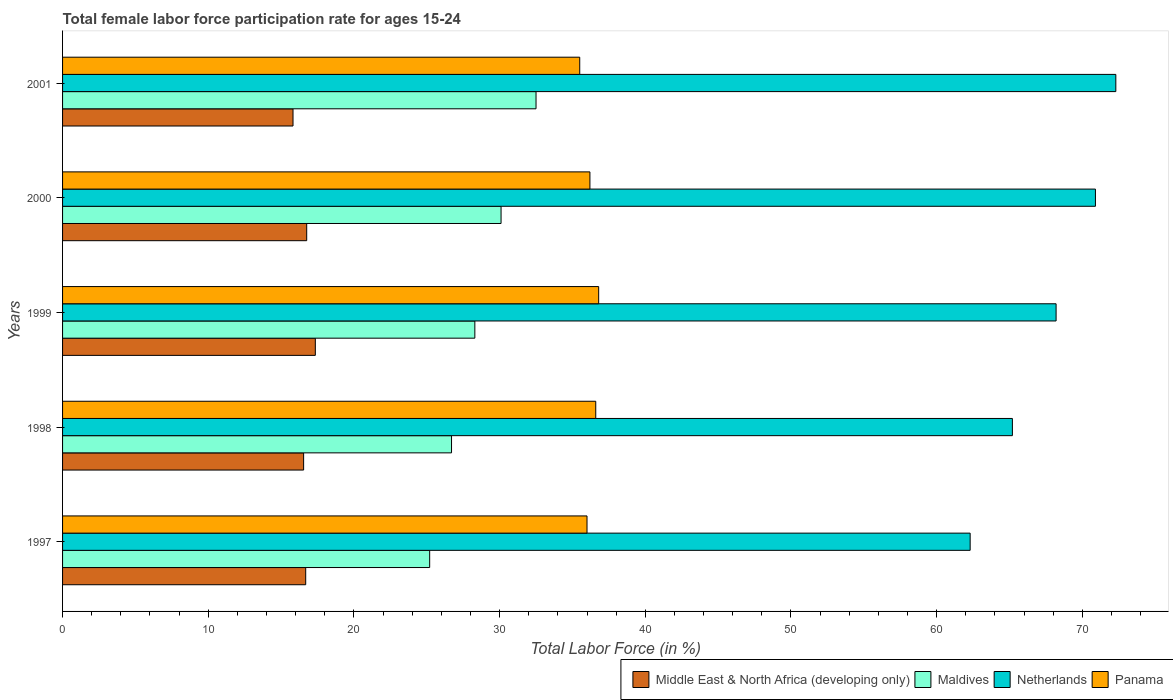How many groups of bars are there?
Your answer should be compact. 5. Are the number of bars per tick equal to the number of legend labels?
Give a very brief answer. Yes. How many bars are there on the 5th tick from the top?
Offer a terse response. 4. What is the label of the 3rd group of bars from the top?
Your response must be concise. 1999. What is the female labor force participation rate in Maldives in 2000?
Offer a very short reply. 30.1. Across all years, what is the maximum female labor force participation rate in Middle East & North Africa (developing only)?
Your answer should be compact. 17.35. Across all years, what is the minimum female labor force participation rate in Middle East & North Africa (developing only)?
Make the answer very short. 15.82. In which year was the female labor force participation rate in Middle East & North Africa (developing only) minimum?
Ensure brevity in your answer.  2001. What is the total female labor force participation rate in Panama in the graph?
Ensure brevity in your answer.  181.1. What is the difference between the female labor force participation rate in Middle East & North Africa (developing only) in 1999 and that in 2001?
Your response must be concise. 1.53. What is the difference between the female labor force participation rate in Maldives in 2000 and the female labor force participation rate in Panama in 2001?
Give a very brief answer. -5.4. What is the average female labor force participation rate in Netherlands per year?
Your answer should be compact. 67.78. In the year 1999, what is the difference between the female labor force participation rate in Maldives and female labor force participation rate in Panama?
Offer a very short reply. -8.5. What is the ratio of the female labor force participation rate in Panama in 1997 to that in 2001?
Provide a succinct answer. 1.01. What is the difference between the highest and the second highest female labor force participation rate in Netherlands?
Provide a succinct answer. 1.4. What is the difference between the highest and the lowest female labor force participation rate in Panama?
Provide a short and direct response. 1.3. In how many years, is the female labor force participation rate in Middle East & North Africa (developing only) greater than the average female labor force participation rate in Middle East & North Africa (developing only) taken over all years?
Give a very brief answer. 3. Is the sum of the female labor force participation rate in Maldives in 1998 and 2000 greater than the maximum female labor force participation rate in Netherlands across all years?
Offer a very short reply. No. What does the 1st bar from the top in 1998 represents?
Your response must be concise. Panama. What does the 2nd bar from the bottom in 2001 represents?
Offer a very short reply. Maldives. Is it the case that in every year, the sum of the female labor force participation rate in Panama and female labor force participation rate in Maldives is greater than the female labor force participation rate in Netherlands?
Give a very brief answer. No. How many bars are there?
Offer a very short reply. 20. How many years are there in the graph?
Your response must be concise. 5. What is the difference between two consecutive major ticks on the X-axis?
Keep it short and to the point. 10. What is the title of the graph?
Provide a succinct answer. Total female labor force participation rate for ages 15-24. Does "Algeria" appear as one of the legend labels in the graph?
Provide a succinct answer. No. What is the Total Labor Force (in %) of Middle East & North Africa (developing only) in 1997?
Provide a succinct answer. 16.69. What is the Total Labor Force (in %) of Maldives in 1997?
Your answer should be very brief. 25.2. What is the Total Labor Force (in %) in Netherlands in 1997?
Provide a short and direct response. 62.3. What is the Total Labor Force (in %) in Middle East & North Africa (developing only) in 1998?
Ensure brevity in your answer.  16.55. What is the Total Labor Force (in %) of Maldives in 1998?
Give a very brief answer. 26.7. What is the Total Labor Force (in %) of Netherlands in 1998?
Provide a short and direct response. 65.2. What is the Total Labor Force (in %) in Panama in 1998?
Give a very brief answer. 36.6. What is the Total Labor Force (in %) of Middle East & North Africa (developing only) in 1999?
Keep it short and to the point. 17.35. What is the Total Labor Force (in %) in Maldives in 1999?
Keep it short and to the point. 28.3. What is the Total Labor Force (in %) of Netherlands in 1999?
Your response must be concise. 68.2. What is the Total Labor Force (in %) of Panama in 1999?
Keep it short and to the point. 36.8. What is the Total Labor Force (in %) in Middle East & North Africa (developing only) in 2000?
Your response must be concise. 16.76. What is the Total Labor Force (in %) of Maldives in 2000?
Offer a very short reply. 30.1. What is the Total Labor Force (in %) in Netherlands in 2000?
Provide a succinct answer. 70.9. What is the Total Labor Force (in %) of Panama in 2000?
Make the answer very short. 36.2. What is the Total Labor Force (in %) of Middle East & North Africa (developing only) in 2001?
Keep it short and to the point. 15.82. What is the Total Labor Force (in %) in Maldives in 2001?
Provide a succinct answer. 32.5. What is the Total Labor Force (in %) of Netherlands in 2001?
Ensure brevity in your answer.  72.3. What is the Total Labor Force (in %) in Panama in 2001?
Ensure brevity in your answer.  35.5. Across all years, what is the maximum Total Labor Force (in %) of Middle East & North Africa (developing only)?
Provide a short and direct response. 17.35. Across all years, what is the maximum Total Labor Force (in %) in Maldives?
Make the answer very short. 32.5. Across all years, what is the maximum Total Labor Force (in %) of Netherlands?
Your answer should be very brief. 72.3. Across all years, what is the maximum Total Labor Force (in %) of Panama?
Provide a succinct answer. 36.8. Across all years, what is the minimum Total Labor Force (in %) in Middle East & North Africa (developing only)?
Keep it short and to the point. 15.82. Across all years, what is the minimum Total Labor Force (in %) of Maldives?
Provide a succinct answer. 25.2. Across all years, what is the minimum Total Labor Force (in %) of Netherlands?
Ensure brevity in your answer.  62.3. Across all years, what is the minimum Total Labor Force (in %) of Panama?
Provide a succinct answer. 35.5. What is the total Total Labor Force (in %) of Middle East & North Africa (developing only) in the graph?
Provide a succinct answer. 83.17. What is the total Total Labor Force (in %) in Maldives in the graph?
Your answer should be compact. 142.8. What is the total Total Labor Force (in %) in Netherlands in the graph?
Your answer should be very brief. 338.9. What is the total Total Labor Force (in %) in Panama in the graph?
Make the answer very short. 181.1. What is the difference between the Total Labor Force (in %) in Middle East & North Africa (developing only) in 1997 and that in 1998?
Offer a terse response. 0.14. What is the difference between the Total Labor Force (in %) in Netherlands in 1997 and that in 1998?
Your response must be concise. -2.9. What is the difference between the Total Labor Force (in %) in Middle East & North Africa (developing only) in 1997 and that in 1999?
Ensure brevity in your answer.  -0.66. What is the difference between the Total Labor Force (in %) of Netherlands in 1997 and that in 1999?
Your response must be concise. -5.9. What is the difference between the Total Labor Force (in %) of Panama in 1997 and that in 1999?
Your answer should be compact. -0.8. What is the difference between the Total Labor Force (in %) in Middle East & North Africa (developing only) in 1997 and that in 2000?
Your response must be concise. -0.07. What is the difference between the Total Labor Force (in %) of Maldives in 1997 and that in 2000?
Make the answer very short. -4.9. What is the difference between the Total Labor Force (in %) in Netherlands in 1997 and that in 2000?
Your answer should be compact. -8.6. What is the difference between the Total Labor Force (in %) of Panama in 1997 and that in 2000?
Provide a succinct answer. -0.2. What is the difference between the Total Labor Force (in %) of Middle East & North Africa (developing only) in 1997 and that in 2001?
Make the answer very short. 0.87. What is the difference between the Total Labor Force (in %) of Middle East & North Africa (developing only) in 1998 and that in 1999?
Your answer should be compact. -0.8. What is the difference between the Total Labor Force (in %) in Middle East & North Africa (developing only) in 1998 and that in 2000?
Provide a short and direct response. -0.21. What is the difference between the Total Labor Force (in %) in Panama in 1998 and that in 2000?
Your answer should be compact. 0.4. What is the difference between the Total Labor Force (in %) in Middle East & North Africa (developing only) in 1998 and that in 2001?
Your answer should be very brief. 0.73. What is the difference between the Total Labor Force (in %) of Netherlands in 1998 and that in 2001?
Offer a very short reply. -7.1. What is the difference between the Total Labor Force (in %) in Panama in 1998 and that in 2001?
Provide a short and direct response. 1.1. What is the difference between the Total Labor Force (in %) in Middle East & North Africa (developing only) in 1999 and that in 2000?
Ensure brevity in your answer.  0.59. What is the difference between the Total Labor Force (in %) of Maldives in 1999 and that in 2000?
Your answer should be compact. -1.8. What is the difference between the Total Labor Force (in %) of Netherlands in 1999 and that in 2000?
Provide a short and direct response. -2.7. What is the difference between the Total Labor Force (in %) in Middle East & North Africa (developing only) in 1999 and that in 2001?
Provide a short and direct response. 1.53. What is the difference between the Total Labor Force (in %) of Middle East & North Africa (developing only) in 2000 and that in 2001?
Offer a very short reply. 0.94. What is the difference between the Total Labor Force (in %) in Maldives in 2000 and that in 2001?
Provide a succinct answer. -2.4. What is the difference between the Total Labor Force (in %) of Panama in 2000 and that in 2001?
Offer a very short reply. 0.7. What is the difference between the Total Labor Force (in %) of Middle East & North Africa (developing only) in 1997 and the Total Labor Force (in %) of Maldives in 1998?
Provide a succinct answer. -10.01. What is the difference between the Total Labor Force (in %) of Middle East & North Africa (developing only) in 1997 and the Total Labor Force (in %) of Netherlands in 1998?
Your answer should be very brief. -48.51. What is the difference between the Total Labor Force (in %) of Middle East & North Africa (developing only) in 1997 and the Total Labor Force (in %) of Panama in 1998?
Offer a terse response. -19.91. What is the difference between the Total Labor Force (in %) of Maldives in 1997 and the Total Labor Force (in %) of Netherlands in 1998?
Provide a short and direct response. -40. What is the difference between the Total Labor Force (in %) of Netherlands in 1997 and the Total Labor Force (in %) of Panama in 1998?
Provide a succinct answer. 25.7. What is the difference between the Total Labor Force (in %) of Middle East & North Africa (developing only) in 1997 and the Total Labor Force (in %) of Maldives in 1999?
Offer a very short reply. -11.61. What is the difference between the Total Labor Force (in %) in Middle East & North Africa (developing only) in 1997 and the Total Labor Force (in %) in Netherlands in 1999?
Your answer should be very brief. -51.51. What is the difference between the Total Labor Force (in %) of Middle East & North Africa (developing only) in 1997 and the Total Labor Force (in %) of Panama in 1999?
Provide a short and direct response. -20.11. What is the difference between the Total Labor Force (in %) in Maldives in 1997 and the Total Labor Force (in %) in Netherlands in 1999?
Provide a succinct answer. -43. What is the difference between the Total Labor Force (in %) of Maldives in 1997 and the Total Labor Force (in %) of Panama in 1999?
Ensure brevity in your answer.  -11.6. What is the difference between the Total Labor Force (in %) in Middle East & North Africa (developing only) in 1997 and the Total Labor Force (in %) in Maldives in 2000?
Offer a very short reply. -13.41. What is the difference between the Total Labor Force (in %) in Middle East & North Africa (developing only) in 1997 and the Total Labor Force (in %) in Netherlands in 2000?
Make the answer very short. -54.21. What is the difference between the Total Labor Force (in %) of Middle East & North Africa (developing only) in 1997 and the Total Labor Force (in %) of Panama in 2000?
Provide a succinct answer. -19.51. What is the difference between the Total Labor Force (in %) of Maldives in 1997 and the Total Labor Force (in %) of Netherlands in 2000?
Offer a very short reply. -45.7. What is the difference between the Total Labor Force (in %) in Netherlands in 1997 and the Total Labor Force (in %) in Panama in 2000?
Provide a succinct answer. 26.1. What is the difference between the Total Labor Force (in %) in Middle East & North Africa (developing only) in 1997 and the Total Labor Force (in %) in Maldives in 2001?
Offer a very short reply. -15.81. What is the difference between the Total Labor Force (in %) of Middle East & North Africa (developing only) in 1997 and the Total Labor Force (in %) of Netherlands in 2001?
Ensure brevity in your answer.  -55.61. What is the difference between the Total Labor Force (in %) in Middle East & North Africa (developing only) in 1997 and the Total Labor Force (in %) in Panama in 2001?
Provide a succinct answer. -18.81. What is the difference between the Total Labor Force (in %) in Maldives in 1997 and the Total Labor Force (in %) in Netherlands in 2001?
Your response must be concise. -47.1. What is the difference between the Total Labor Force (in %) of Netherlands in 1997 and the Total Labor Force (in %) of Panama in 2001?
Your response must be concise. 26.8. What is the difference between the Total Labor Force (in %) in Middle East & North Africa (developing only) in 1998 and the Total Labor Force (in %) in Maldives in 1999?
Offer a terse response. -11.75. What is the difference between the Total Labor Force (in %) in Middle East & North Africa (developing only) in 1998 and the Total Labor Force (in %) in Netherlands in 1999?
Offer a very short reply. -51.65. What is the difference between the Total Labor Force (in %) in Middle East & North Africa (developing only) in 1998 and the Total Labor Force (in %) in Panama in 1999?
Your response must be concise. -20.25. What is the difference between the Total Labor Force (in %) of Maldives in 1998 and the Total Labor Force (in %) of Netherlands in 1999?
Your response must be concise. -41.5. What is the difference between the Total Labor Force (in %) in Netherlands in 1998 and the Total Labor Force (in %) in Panama in 1999?
Give a very brief answer. 28.4. What is the difference between the Total Labor Force (in %) in Middle East & North Africa (developing only) in 1998 and the Total Labor Force (in %) in Maldives in 2000?
Offer a very short reply. -13.55. What is the difference between the Total Labor Force (in %) in Middle East & North Africa (developing only) in 1998 and the Total Labor Force (in %) in Netherlands in 2000?
Ensure brevity in your answer.  -54.35. What is the difference between the Total Labor Force (in %) of Middle East & North Africa (developing only) in 1998 and the Total Labor Force (in %) of Panama in 2000?
Your response must be concise. -19.65. What is the difference between the Total Labor Force (in %) in Maldives in 1998 and the Total Labor Force (in %) in Netherlands in 2000?
Your answer should be very brief. -44.2. What is the difference between the Total Labor Force (in %) in Netherlands in 1998 and the Total Labor Force (in %) in Panama in 2000?
Ensure brevity in your answer.  29. What is the difference between the Total Labor Force (in %) of Middle East & North Africa (developing only) in 1998 and the Total Labor Force (in %) of Maldives in 2001?
Your answer should be compact. -15.95. What is the difference between the Total Labor Force (in %) of Middle East & North Africa (developing only) in 1998 and the Total Labor Force (in %) of Netherlands in 2001?
Give a very brief answer. -55.75. What is the difference between the Total Labor Force (in %) of Middle East & North Africa (developing only) in 1998 and the Total Labor Force (in %) of Panama in 2001?
Ensure brevity in your answer.  -18.95. What is the difference between the Total Labor Force (in %) in Maldives in 1998 and the Total Labor Force (in %) in Netherlands in 2001?
Give a very brief answer. -45.6. What is the difference between the Total Labor Force (in %) of Netherlands in 1998 and the Total Labor Force (in %) of Panama in 2001?
Make the answer very short. 29.7. What is the difference between the Total Labor Force (in %) of Middle East & North Africa (developing only) in 1999 and the Total Labor Force (in %) of Maldives in 2000?
Offer a terse response. -12.75. What is the difference between the Total Labor Force (in %) in Middle East & North Africa (developing only) in 1999 and the Total Labor Force (in %) in Netherlands in 2000?
Your answer should be very brief. -53.55. What is the difference between the Total Labor Force (in %) in Middle East & North Africa (developing only) in 1999 and the Total Labor Force (in %) in Panama in 2000?
Keep it short and to the point. -18.85. What is the difference between the Total Labor Force (in %) of Maldives in 1999 and the Total Labor Force (in %) of Netherlands in 2000?
Your response must be concise. -42.6. What is the difference between the Total Labor Force (in %) in Maldives in 1999 and the Total Labor Force (in %) in Panama in 2000?
Make the answer very short. -7.9. What is the difference between the Total Labor Force (in %) in Netherlands in 1999 and the Total Labor Force (in %) in Panama in 2000?
Offer a terse response. 32. What is the difference between the Total Labor Force (in %) of Middle East & North Africa (developing only) in 1999 and the Total Labor Force (in %) of Maldives in 2001?
Your answer should be very brief. -15.15. What is the difference between the Total Labor Force (in %) in Middle East & North Africa (developing only) in 1999 and the Total Labor Force (in %) in Netherlands in 2001?
Keep it short and to the point. -54.95. What is the difference between the Total Labor Force (in %) of Middle East & North Africa (developing only) in 1999 and the Total Labor Force (in %) of Panama in 2001?
Provide a short and direct response. -18.15. What is the difference between the Total Labor Force (in %) of Maldives in 1999 and the Total Labor Force (in %) of Netherlands in 2001?
Provide a succinct answer. -44. What is the difference between the Total Labor Force (in %) of Netherlands in 1999 and the Total Labor Force (in %) of Panama in 2001?
Offer a very short reply. 32.7. What is the difference between the Total Labor Force (in %) of Middle East & North Africa (developing only) in 2000 and the Total Labor Force (in %) of Maldives in 2001?
Give a very brief answer. -15.74. What is the difference between the Total Labor Force (in %) in Middle East & North Africa (developing only) in 2000 and the Total Labor Force (in %) in Netherlands in 2001?
Your answer should be compact. -55.54. What is the difference between the Total Labor Force (in %) in Middle East & North Africa (developing only) in 2000 and the Total Labor Force (in %) in Panama in 2001?
Give a very brief answer. -18.74. What is the difference between the Total Labor Force (in %) in Maldives in 2000 and the Total Labor Force (in %) in Netherlands in 2001?
Make the answer very short. -42.2. What is the difference between the Total Labor Force (in %) of Netherlands in 2000 and the Total Labor Force (in %) of Panama in 2001?
Keep it short and to the point. 35.4. What is the average Total Labor Force (in %) in Middle East & North Africa (developing only) per year?
Your answer should be very brief. 16.63. What is the average Total Labor Force (in %) of Maldives per year?
Offer a terse response. 28.56. What is the average Total Labor Force (in %) of Netherlands per year?
Your answer should be very brief. 67.78. What is the average Total Labor Force (in %) of Panama per year?
Your answer should be compact. 36.22. In the year 1997, what is the difference between the Total Labor Force (in %) in Middle East & North Africa (developing only) and Total Labor Force (in %) in Maldives?
Offer a terse response. -8.51. In the year 1997, what is the difference between the Total Labor Force (in %) in Middle East & North Africa (developing only) and Total Labor Force (in %) in Netherlands?
Offer a very short reply. -45.61. In the year 1997, what is the difference between the Total Labor Force (in %) of Middle East & North Africa (developing only) and Total Labor Force (in %) of Panama?
Your answer should be very brief. -19.31. In the year 1997, what is the difference between the Total Labor Force (in %) in Maldives and Total Labor Force (in %) in Netherlands?
Offer a terse response. -37.1. In the year 1997, what is the difference between the Total Labor Force (in %) in Maldives and Total Labor Force (in %) in Panama?
Give a very brief answer. -10.8. In the year 1997, what is the difference between the Total Labor Force (in %) of Netherlands and Total Labor Force (in %) of Panama?
Ensure brevity in your answer.  26.3. In the year 1998, what is the difference between the Total Labor Force (in %) in Middle East & North Africa (developing only) and Total Labor Force (in %) in Maldives?
Your response must be concise. -10.15. In the year 1998, what is the difference between the Total Labor Force (in %) of Middle East & North Africa (developing only) and Total Labor Force (in %) of Netherlands?
Make the answer very short. -48.65. In the year 1998, what is the difference between the Total Labor Force (in %) of Middle East & North Africa (developing only) and Total Labor Force (in %) of Panama?
Give a very brief answer. -20.05. In the year 1998, what is the difference between the Total Labor Force (in %) in Maldives and Total Labor Force (in %) in Netherlands?
Keep it short and to the point. -38.5. In the year 1998, what is the difference between the Total Labor Force (in %) in Netherlands and Total Labor Force (in %) in Panama?
Offer a very short reply. 28.6. In the year 1999, what is the difference between the Total Labor Force (in %) of Middle East & North Africa (developing only) and Total Labor Force (in %) of Maldives?
Keep it short and to the point. -10.95. In the year 1999, what is the difference between the Total Labor Force (in %) in Middle East & North Africa (developing only) and Total Labor Force (in %) in Netherlands?
Your answer should be compact. -50.85. In the year 1999, what is the difference between the Total Labor Force (in %) of Middle East & North Africa (developing only) and Total Labor Force (in %) of Panama?
Offer a terse response. -19.45. In the year 1999, what is the difference between the Total Labor Force (in %) of Maldives and Total Labor Force (in %) of Netherlands?
Your answer should be very brief. -39.9. In the year 1999, what is the difference between the Total Labor Force (in %) of Netherlands and Total Labor Force (in %) of Panama?
Ensure brevity in your answer.  31.4. In the year 2000, what is the difference between the Total Labor Force (in %) in Middle East & North Africa (developing only) and Total Labor Force (in %) in Maldives?
Your answer should be very brief. -13.34. In the year 2000, what is the difference between the Total Labor Force (in %) in Middle East & North Africa (developing only) and Total Labor Force (in %) in Netherlands?
Offer a terse response. -54.14. In the year 2000, what is the difference between the Total Labor Force (in %) of Middle East & North Africa (developing only) and Total Labor Force (in %) of Panama?
Keep it short and to the point. -19.44. In the year 2000, what is the difference between the Total Labor Force (in %) in Maldives and Total Labor Force (in %) in Netherlands?
Give a very brief answer. -40.8. In the year 2000, what is the difference between the Total Labor Force (in %) in Maldives and Total Labor Force (in %) in Panama?
Your answer should be compact. -6.1. In the year 2000, what is the difference between the Total Labor Force (in %) in Netherlands and Total Labor Force (in %) in Panama?
Offer a terse response. 34.7. In the year 2001, what is the difference between the Total Labor Force (in %) of Middle East & North Africa (developing only) and Total Labor Force (in %) of Maldives?
Your answer should be very brief. -16.68. In the year 2001, what is the difference between the Total Labor Force (in %) in Middle East & North Africa (developing only) and Total Labor Force (in %) in Netherlands?
Your answer should be compact. -56.48. In the year 2001, what is the difference between the Total Labor Force (in %) in Middle East & North Africa (developing only) and Total Labor Force (in %) in Panama?
Ensure brevity in your answer.  -19.68. In the year 2001, what is the difference between the Total Labor Force (in %) of Maldives and Total Labor Force (in %) of Netherlands?
Your answer should be compact. -39.8. In the year 2001, what is the difference between the Total Labor Force (in %) of Maldives and Total Labor Force (in %) of Panama?
Keep it short and to the point. -3. In the year 2001, what is the difference between the Total Labor Force (in %) in Netherlands and Total Labor Force (in %) in Panama?
Make the answer very short. 36.8. What is the ratio of the Total Labor Force (in %) in Middle East & North Africa (developing only) in 1997 to that in 1998?
Your answer should be very brief. 1.01. What is the ratio of the Total Labor Force (in %) in Maldives in 1997 to that in 1998?
Make the answer very short. 0.94. What is the ratio of the Total Labor Force (in %) in Netherlands in 1997 to that in 1998?
Offer a terse response. 0.96. What is the ratio of the Total Labor Force (in %) in Panama in 1997 to that in 1998?
Keep it short and to the point. 0.98. What is the ratio of the Total Labor Force (in %) of Middle East & North Africa (developing only) in 1997 to that in 1999?
Your answer should be very brief. 0.96. What is the ratio of the Total Labor Force (in %) in Maldives in 1997 to that in 1999?
Provide a succinct answer. 0.89. What is the ratio of the Total Labor Force (in %) in Netherlands in 1997 to that in 1999?
Make the answer very short. 0.91. What is the ratio of the Total Labor Force (in %) of Panama in 1997 to that in 1999?
Offer a terse response. 0.98. What is the ratio of the Total Labor Force (in %) in Middle East & North Africa (developing only) in 1997 to that in 2000?
Give a very brief answer. 1. What is the ratio of the Total Labor Force (in %) of Maldives in 1997 to that in 2000?
Your answer should be very brief. 0.84. What is the ratio of the Total Labor Force (in %) in Netherlands in 1997 to that in 2000?
Give a very brief answer. 0.88. What is the ratio of the Total Labor Force (in %) of Panama in 1997 to that in 2000?
Provide a succinct answer. 0.99. What is the ratio of the Total Labor Force (in %) in Middle East & North Africa (developing only) in 1997 to that in 2001?
Give a very brief answer. 1.06. What is the ratio of the Total Labor Force (in %) in Maldives in 1997 to that in 2001?
Keep it short and to the point. 0.78. What is the ratio of the Total Labor Force (in %) in Netherlands in 1997 to that in 2001?
Give a very brief answer. 0.86. What is the ratio of the Total Labor Force (in %) in Panama in 1997 to that in 2001?
Keep it short and to the point. 1.01. What is the ratio of the Total Labor Force (in %) of Middle East & North Africa (developing only) in 1998 to that in 1999?
Keep it short and to the point. 0.95. What is the ratio of the Total Labor Force (in %) in Maldives in 1998 to that in 1999?
Ensure brevity in your answer.  0.94. What is the ratio of the Total Labor Force (in %) of Netherlands in 1998 to that in 1999?
Provide a short and direct response. 0.96. What is the ratio of the Total Labor Force (in %) of Panama in 1998 to that in 1999?
Your answer should be very brief. 0.99. What is the ratio of the Total Labor Force (in %) of Middle East & North Africa (developing only) in 1998 to that in 2000?
Your answer should be very brief. 0.99. What is the ratio of the Total Labor Force (in %) in Maldives in 1998 to that in 2000?
Keep it short and to the point. 0.89. What is the ratio of the Total Labor Force (in %) in Netherlands in 1998 to that in 2000?
Offer a very short reply. 0.92. What is the ratio of the Total Labor Force (in %) of Panama in 1998 to that in 2000?
Make the answer very short. 1.01. What is the ratio of the Total Labor Force (in %) of Middle East & North Africa (developing only) in 1998 to that in 2001?
Your response must be concise. 1.05. What is the ratio of the Total Labor Force (in %) of Maldives in 1998 to that in 2001?
Keep it short and to the point. 0.82. What is the ratio of the Total Labor Force (in %) of Netherlands in 1998 to that in 2001?
Offer a very short reply. 0.9. What is the ratio of the Total Labor Force (in %) of Panama in 1998 to that in 2001?
Your response must be concise. 1.03. What is the ratio of the Total Labor Force (in %) in Middle East & North Africa (developing only) in 1999 to that in 2000?
Give a very brief answer. 1.04. What is the ratio of the Total Labor Force (in %) of Maldives in 1999 to that in 2000?
Your response must be concise. 0.94. What is the ratio of the Total Labor Force (in %) in Netherlands in 1999 to that in 2000?
Provide a succinct answer. 0.96. What is the ratio of the Total Labor Force (in %) of Panama in 1999 to that in 2000?
Offer a very short reply. 1.02. What is the ratio of the Total Labor Force (in %) in Middle East & North Africa (developing only) in 1999 to that in 2001?
Offer a very short reply. 1.1. What is the ratio of the Total Labor Force (in %) of Maldives in 1999 to that in 2001?
Keep it short and to the point. 0.87. What is the ratio of the Total Labor Force (in %) in Netherlands in 1999 to that in 2001?
Provide a succinct answer. 0.94. What is the ratio of the Total Labor Force (in %) in Panama in 1999 to that in 2001?
Provide a succinct answer. 1.04. What is the ratio of the Total Labor Force (in %) in Middle East & North Africa (developing only) in 2000 to that in 2001?
Offer a very short reply. 1.06. What is the ratio of the Total Labor Force (in %) in Maldives in 2000 to that in 2001?
Ensure brevity in your answer.  0.93. What is the ratio of the Total Labor Force (in %) of Netherlands in 2000 to that in 2001?
Keep it short and to the point. 0.98. What is the ratio of the Total Labor Force (in %) of Panama in 2000 to that in 2001?
Provide a succinct answer. 1.02. What is the difference between the highest and the second highest Total Labor Force (in %) of Middle East & North Africa (developing only)?
Your answer should be very brief. 0.59. What is the difference between the highest and the second highest Total Labor Force (in %) in Netherlands?
Provide a short and direct response. 1.4. What is the difference between the highest and the second highest Total Labor Force (in %) of Panama?
Provide a succinct answer. 0.2. What is the difference between the highest and the lowest Total Labor Force (in %) of Middle East & North Africa (developing only)?
Provide a short and direct response. 1.53. What is the difference between the highest and the lowest Total Labor Force (in %) of Panama?
Provide a succinct answer. 1.3. 